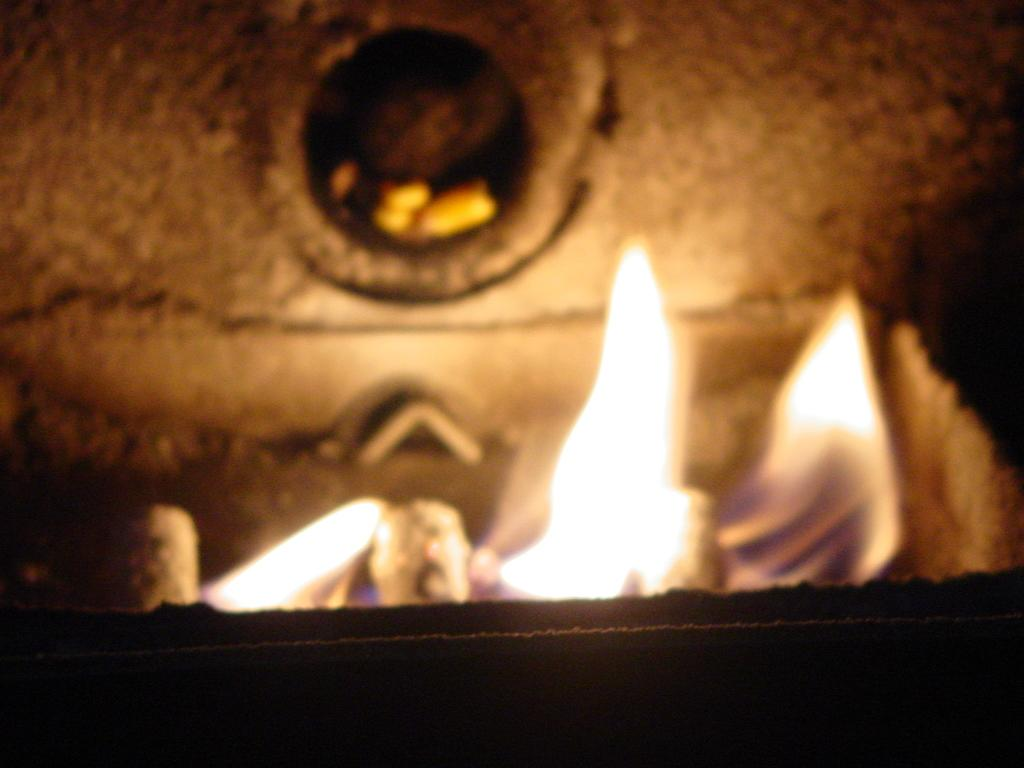What is present in the image that indicates heat or fire? There are flames in the image. How would you describe the lower portion of the image? The bottom part of the image is dark. What can be observed about the background of the image? The background of the image is blurred. Are there any slaves depicted in the image? There is no mention or indication of slaves in the image. Can you see any fairies flying around in the image? There is no mention or indication of fairies in the image. 